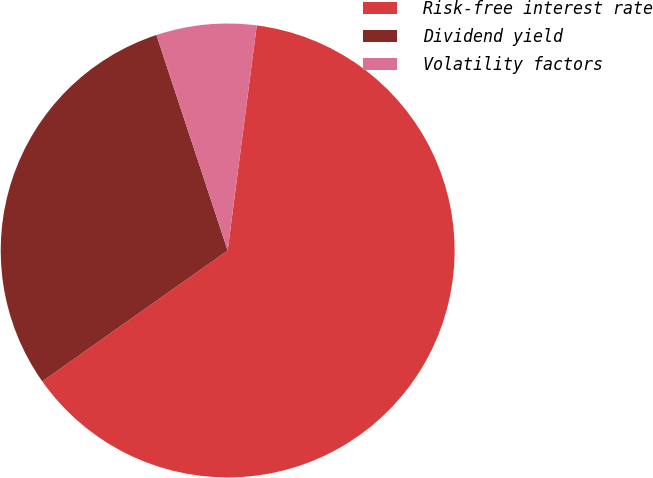Convert chart. <chart><loc_0><loc_0><loc_500><loc_500><pie_chart><fcel>Risk-free interest rate<fcel>Dividend yield<fcel>Volatility factors<nl><fcel>63.17%<fcel>29.7%<fcel>7.13%<nl></chart> 